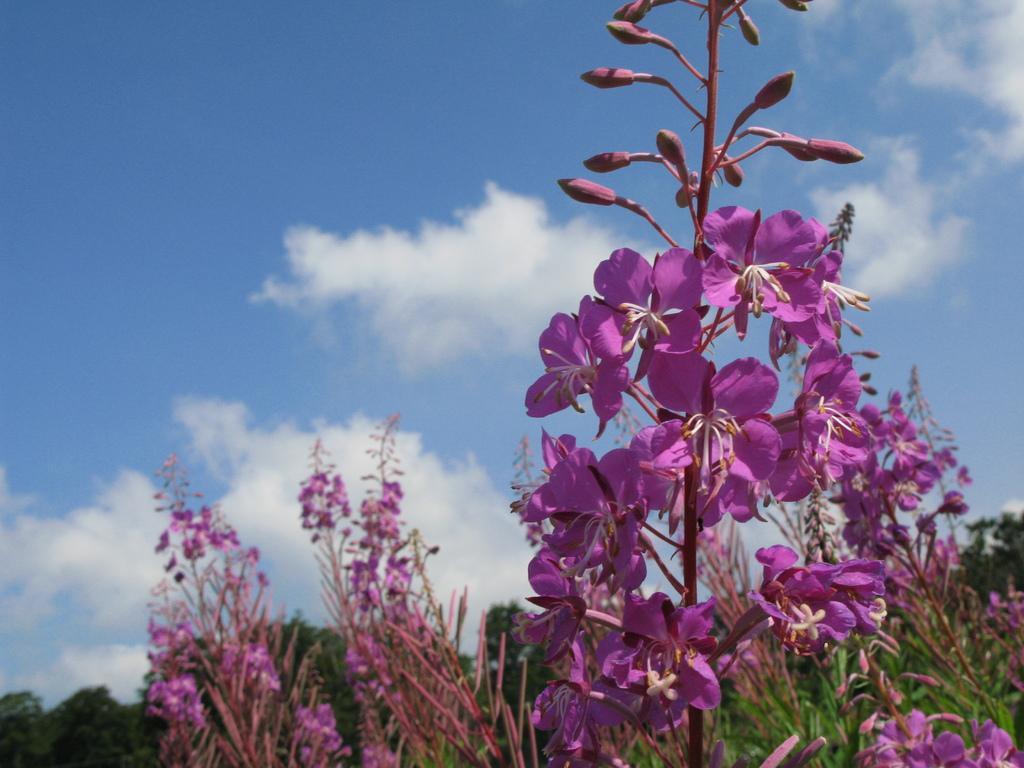Can you describe this image briefly? In the center of the image we can see plants and flowers, which are in pink color. In the background, we can see the sky, clouds, trees etc. 